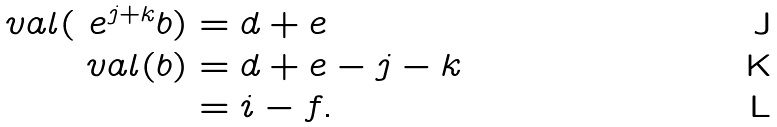Convert formula to latex. <formula><loc_0><loc_0><loc_500><loc_500>\ v a l ( \ e ^ { j + k } b ) & = d + e \\ \ v a l ( b ) & = d + e - j - k \\ & = i - f .</formula> 